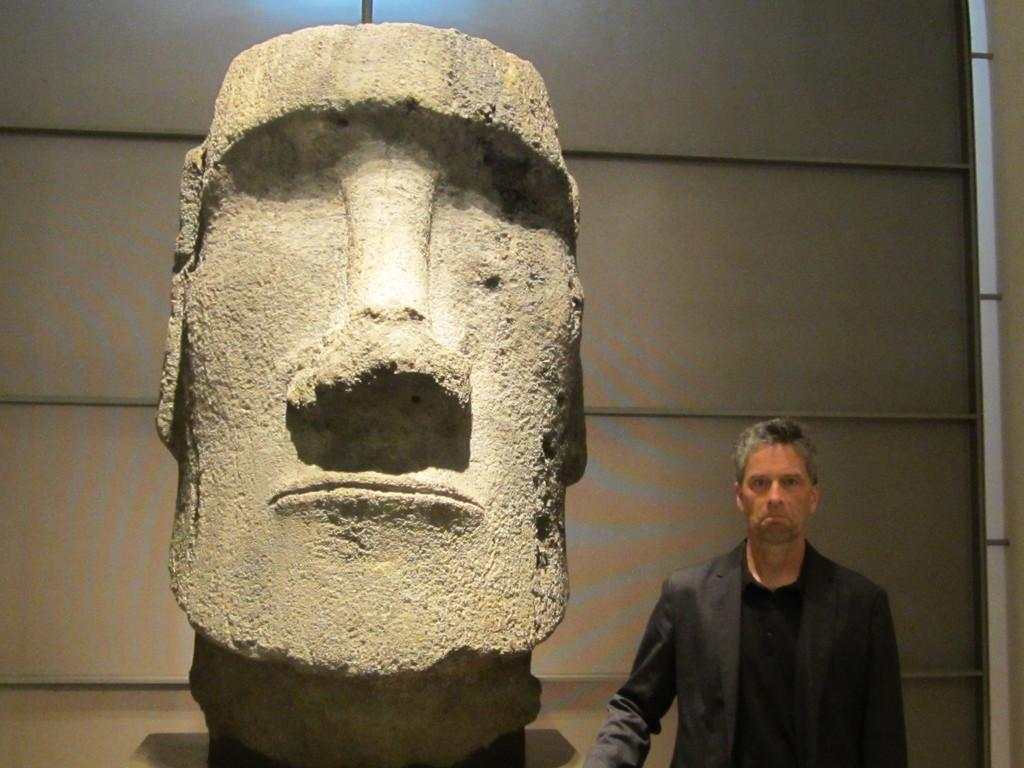What is the main subject in the center of the image? There is a sculpture in the center of the image. Can you describe the man's position in the image? There is a man standing on the bottom right of the image. How many monkeys are sitting on the sculpture in the image? There are no monkeys present in the image; it only features a sculpture and a man. How many girls are standing next to the man in the image? There is no mention of girls in the image; it only features a sculpture and a man. 